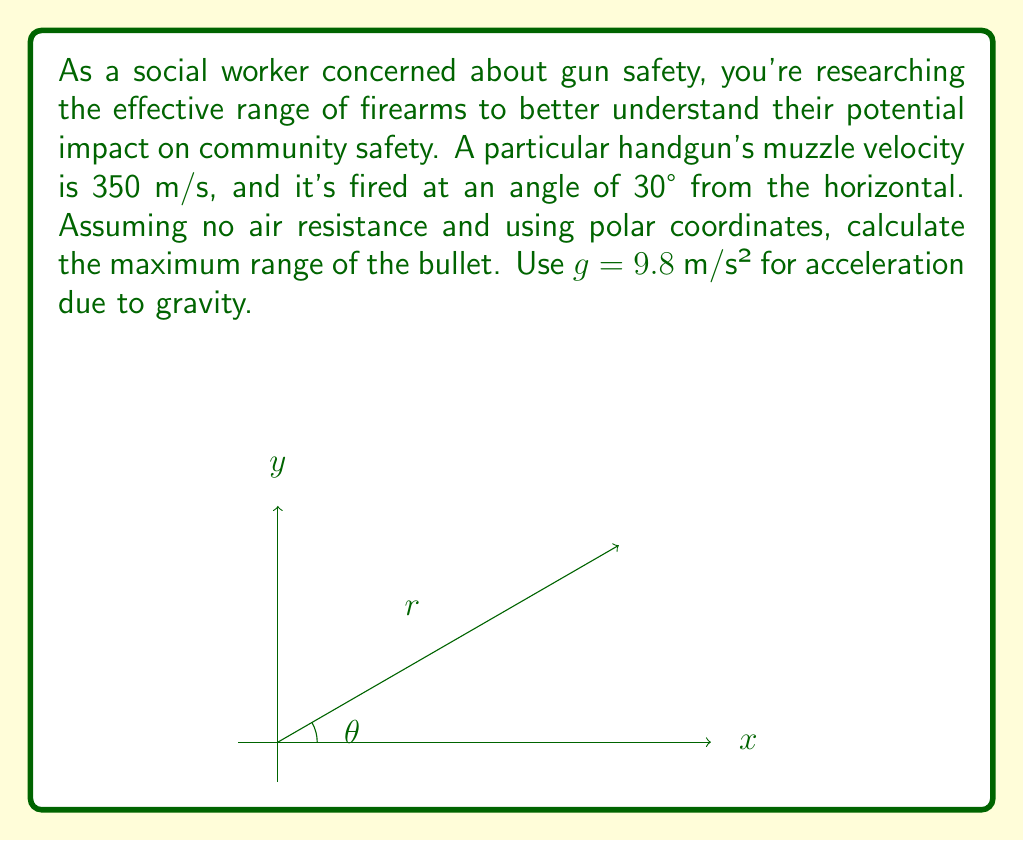What is the answer to this math problem? Let's approach this step-by-step using polar coordinates:

1) In polar coordinates, the position of the bullet is given by $(r, \theta)$, where $r$ is the distance from the origin and $\theta$ is the angle from the horizontal.

2) The components of velocity in polar coordinates are:
   $$v_r = \frac{dr}{dt}, \quad v_\theta = r\frac{d\theta}{dt}$$

3) Initially, $v_r = v \cos 30°$ and $v_\theta = v \sin 30°$, where $v = 350$ m/s.

4) The equations of motion in polar coordinates are:
   $$\frac{d^2r}{dt^2} - r\left(\frac{d\theta}{dt}\right)^2 = -g\cos\theta$$
   $$r\frac{d^2\theta}{dt^2} + 2\frac{dr}{dt}\frac{d\theta}{dt} = -g\sin\theta$$

5) For the maximum range, we're interested in when the bullet hits the ground, i.e., when $\theta = 0$ again.

6) The time of flight is given by:
   $$t = \frac{2v\sin 30°}{g} = \frac{2 \cdot 350 \cdot 0.5}{9.8} \approx 35.71 \text{ seconds}$$

7) The range in Cartesian coordinates would be:
   $$R = v\cos 30° \cdot t = 350 \cdot \frac{\sqrt{3}}{2} \cdot 35.71 \approx 10,800 \text{ meters}$$

8) To convert this to polar coordinates, we use:
   $$r = \sqrt{x^2 + y^2} = R = 10,800 \text{ meters}$$
   $$\theta = 0 \text{ (at the point of impact)}$$

Therefore, in polar coordinates, the maximum range is represented by $(10800, 0)$.
Answer: $(10800, 0)$ in polar coordinates $(r, \theta)$ 